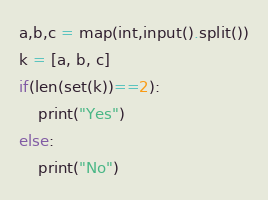<code> <loc_0><loc_0><loc_500><loc_500><_Python_>a,b,c = map(int,input().split())
k = [a, b, c]
if(len(set(k))==2):
    print("Yes")
else:
    print("No")</code> 